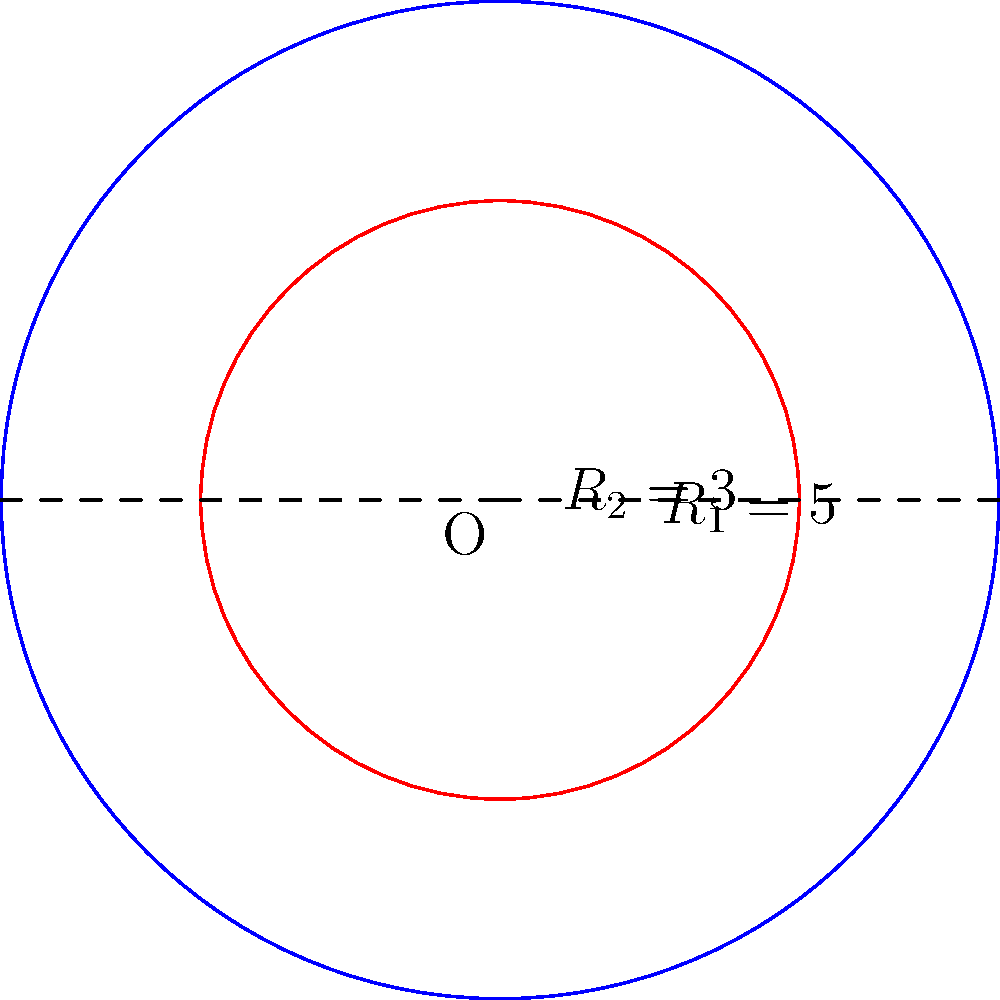In a cost-efficient office layout design, two concentric circular areas are proposed. The outer circle has a radius of 5 meters, while the inner circle has a radius of 3 meters. What is the area of the ring-shaped region between these two circles? Round your answer to two decimal places. Let's approach this step-by-step:

1) The area of a circle is given by the formula $A = \pi r^2$, where $r$ is the radius.

2) For the outer circle (radius $R_1 = 5$ m):
   $A_1 = \pi (5)^2 = 25\pi$ sq meters

3) For the inner circle (radius $R_2 = 3$ m):
   $A_2 = \pi (3)^2 = 9\pi$ sq meters

4) The area of the ring is the difference between these two areas:
   $A_{ring} = A_1 - A_2 = 25\pi - 9\pi = 16\pi$ sq meters

5) Calculating this:
   $16\pi \approx 50.2655$ sq meters

6) Rounding to two decimal places:
   $50.27$ sq meters
Answer: $50.27$ sq meters 